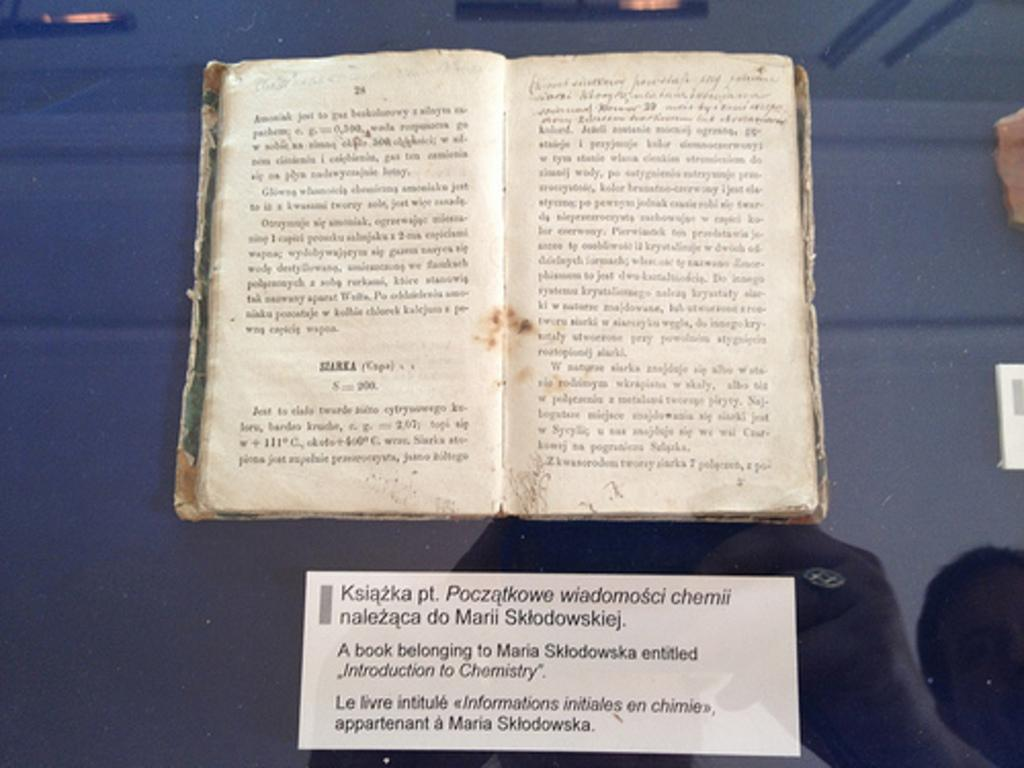Provide a one-sentence caption for the provided image. A book on display with a card stating it was owned by Maria Sklofowska. 